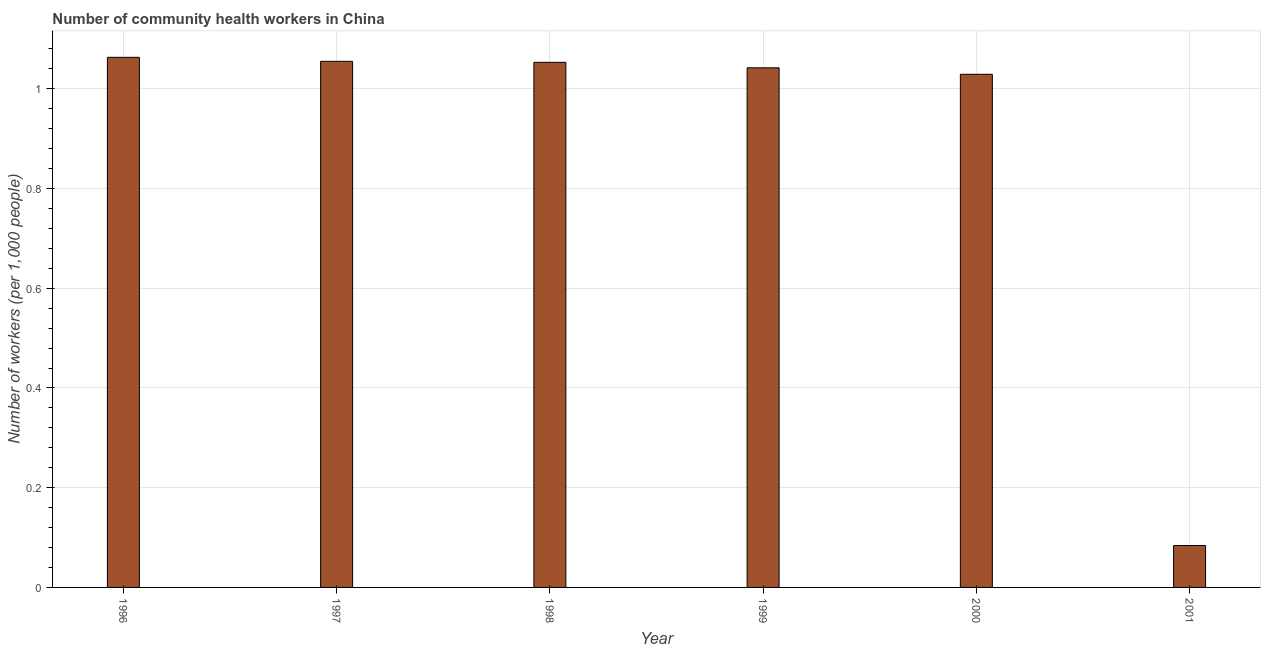Does the graph contain grids?
Your answer should be compact. Yes. What is the title of the graph?
Your answer should be very brief. Number of community health workers in China. What is the label or title of the X-axis?
Provide a short and direct response. Year. What is the label or title of the Y-axis?
Provide a short and direct response. Number of workers (per 1,0 people). What is the number of community health workers in 1998?
Offer a terse response. 1.05. Across all years, what is the maximum number of community health workers?
Keep it short and to the point. 1.06. Across all years, what is the minimum number of community health workers?
Give a very brief answer. 0.08. In which year was the number of community health workers maximum?
Keep it short and to the point. 1996. What is the sum of the number of community health workers?
Offer a very short reply. 5.33. What is the difference between the number of community health workers in 1998 and 2000?
Keep it short and to the point. 0.02. What is the average number of community health workers per year?
Provide a succinct answer. 0.89. What is the median number of community health workers?
Your response must be concise. 1.05. In how many years, is the number of community health workers greater than 0.12 ?
Provide a succinct answer. 5. What is the difference between the highest and the second highest number of community health workers?
Offer a terse response. 0.01. Is the sum of the number of community health workers in 1996 and 2000 greater than the maximum number of community health workers across all years?
Your answer should be very brief. Yes. What is the difference between the highest and the lowest number of community health workers?
Keep it short and to the point. 0.98. Are all the bars in the graph horizontal?
Give a very brief answer. No. What is the Number of workers (per 1,000 people) of 1996?
Ensure brevity in your answer.  1.06. What is the Number of workers (per 1,000 people) of 1997?
Make the answer very short. 1.05. What is the Number of workers (per 1,000 people) in 1998?
Provide a short and direct response. 1.05. What is the Number of workers (per 1,000 people) in 1999?
Your response must be concise. 1.04. What is the Number of workers (per 1,000 people) of 2001?
Provide a succinct answer. 0.08. What is the difference between the Number of workers (per 1,000 people) in 1996 and 1997?
Make the answer very short. 0.01. What is the difference between the Number of workers (per 1,000 people) in 1996 and 1998?
Provide a short and direct response. 0.01. What is the difference between the Number of workers (per 1,000 people) in 1996 and 1999?
Make the answer very short. 0.02. What is the difference between the Number of workers (per 1,000 people) in 1996 and 2000?
Provide a succinct answer. 0.03. What is the difference between the Number of workers (per 1,000 people) in 1997 and 1998?
Your response must be concise. 0. What is the difference between the Number of workers (per 1,000 people) in 1997 and 1999?
Keep it short and to the point. 0.01. What is the difference between the Number of workers (per 1,000 people) in 1997 and 2000?
Provide a succinct answer. 0.03. What is the difference between the Number of workers (per 1,000 people) in 1998 and 1999?
Provide a short and direct response. 0.01. What is the difference between the Number of workers (per 1,000 people) in 1998 and 2000?
Offer a very short reply. 0.02. What is the difference between the Number of workers (per 1,000 people) in 1998 and 2001?
Provide a succinct answer. 0.97. What is the difference between the Number of workers (per 1,000 people) in 1999 and 2000?
Ensure brevity in your answer.  0.01. What is the difference between the Number of workers (per 1,000 people) in 1999 and 2001?
Provide a short and direct response. 0.96. What is the difference between the Number of workers (per 1,000 people) in 2000 and 2001?
Make the answer very short. 0.94. What is the ratio of the Number of workers (per 1,000 people) in 1996 to that in 1998?
Provide a succinct answer. 1.01. What is the ratio of the Number of workers (per 1,000 people) in 1996 to that in 1999?
Ensure brevity in your answer.  1.02. What is the ratio of the Number of workers (per 1,000 people) in 1996 to that in 2000?
Give a very brief answer. 1.03. What is the ratio of the Number of workers (per 1,000 people) in 1996 to that in 2001?
Give a very brief answer. 12.65. What is the ratio of the Number of workers (per 1,000 people) in 1997 to that in 2000?
Offer a very short reply. 1.02. What is the ratio of the Number of workers (per 1,000 people) in 1997 to that in 2001?
Provide a succinct answer. 12.56. What is the ratio of the Number of workers (per 1,000 people) in 1998 to that in 2001?
Make the answer very short. 12.54. What is the ratio of the Number of workers (per 1,000 people) in 1999 to that in 2000?
Offer a very short reply. 1.01. What is the ratio of the Number of workers (per 1,000 people) in 1999 to that in 2001?
Your answer should be compact. 12.4. What is the ratio of the Number of workers (per 1,000 people) in 2000 to that in 2001?
Your answer should be compact. 12.25. 